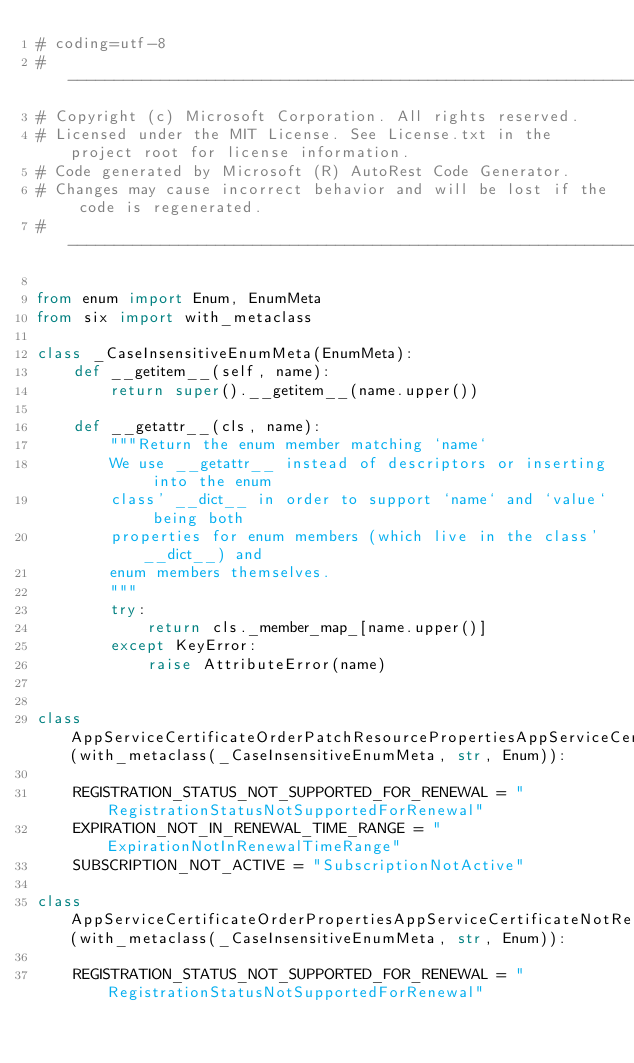<code> <loc_0><loc_0><loc_500><loc_500><_Python_># coding=utf-8
# --------------------------------------------------------------------------
# Copyright (c) Microsoft Corporation. All rights reserved.
# Licensed under the MIT License. See License.txt in the project root for license information.
# Code generated by Microsoft (R) AutoRest Code Generator.
# Changes may cause incorrect behavior and will be lost if the code is regenerated.
# --------------------------------------------------------------------------

from enum import Enum, EnumMeta
from six import with_metaclass

class _CaseInsensitiveEnumMeta(EnumMeta):
    def __getitem__(self, name):
        return super().__getitem__(name.upper())

    def __getattr__(cls, name):
        """Return the enum member matching `name`
        We use __getattr__ instead of descriptors or inserting into the enum
        class' __dict__ in order to support `name` and `value` being both
        properties for enum members (which live in the class' __dict__) and
        enum members themselves.
        """
        try:
            return cls._member_map_[name.upper()]
        except KeyError:
            raise AttributeError(name)


class AppServiceCertificateOrderPatchResourcePropertiesAppServiceCertificateNotRenewableReasonsItem(with_metaclass(_CaseInsensitiveEnumMeta, str, Enum)):

    REGISTRATION_STATUS_NOT_SUPPORTED_FOR_RENEWAL = "RegistrationStatusNotSupportedForRenewal"
    EXPIRATION_NOT_IN_RENEWAL_TIME_RANGE = "ExpirationNotInRenewalTimeRange"
    SUBSCRIPTION_NOT_ACTIVE = "SubscriptionNotActive"

class AppServiceCertificateOrderPropertiesAppServiceCertificateNotRenewableReasonsItem(with_metaclass(_CaseInsensitiveEnumMeta, str, Enum)):

    REGISTRATION_STATUS_NOT_SUPPORTED_FOR_RENEWAL = "RegistrationStatusNotSupportedForRenewal"</code> 